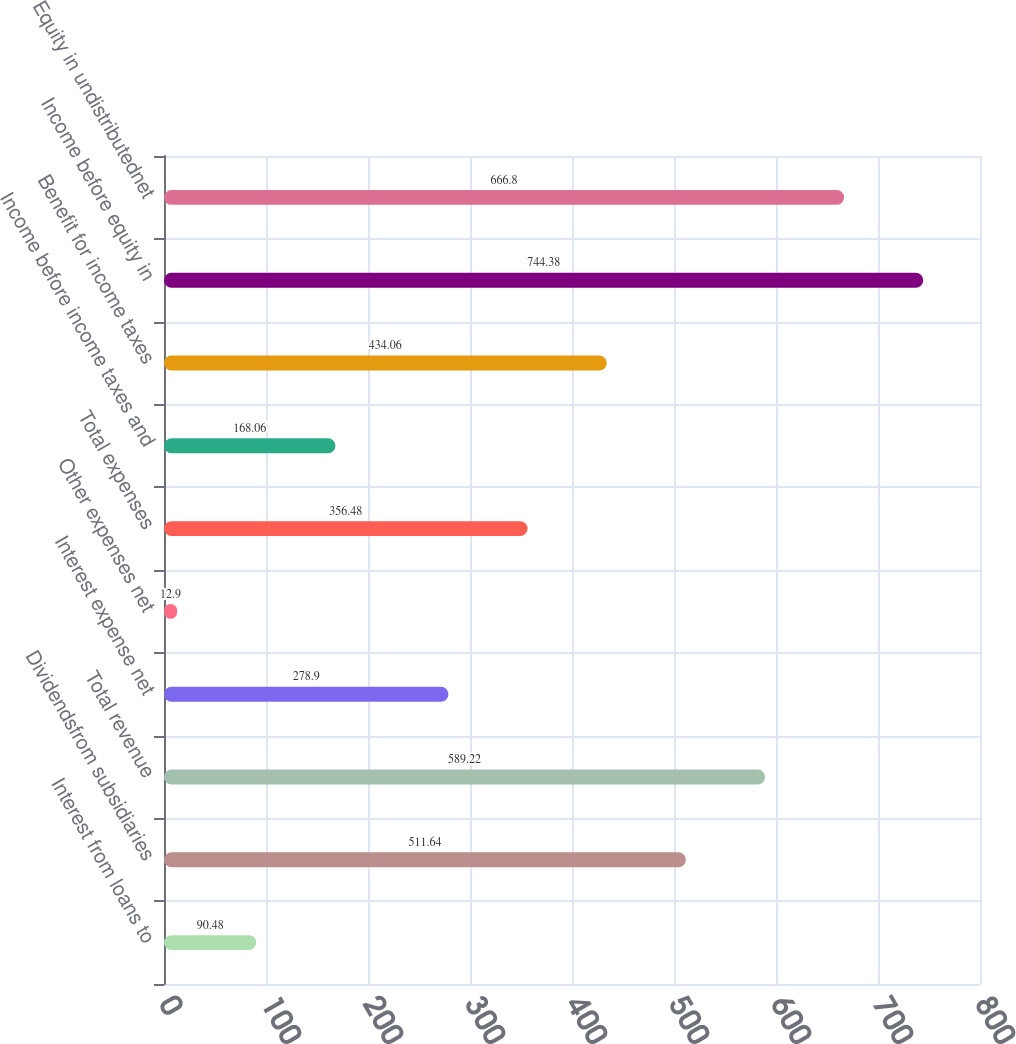<chart> <loc_0><loc_0><loc_500><loc_500><bar_chart><fcel>Interest from loans to<fcel>Dividendsfrom subsidiaries<fcel>Total revenue<fcel>Interest expense net<fcel>Other expenses net<fcel>Total expenses<fcel>Income before income taxes and<fcel>Benefit for income taxes<fcel>Income before equity in<fcel>Equity in undistributednet<nl><fcel>90.48<fcel>511.64<fcel>589.22<fcel>278.9<fcel>12.9<fcel>356.48<fcel>168.06<fcel>434.06<fcel>744.38<fcel>666.8<nl></chart> 